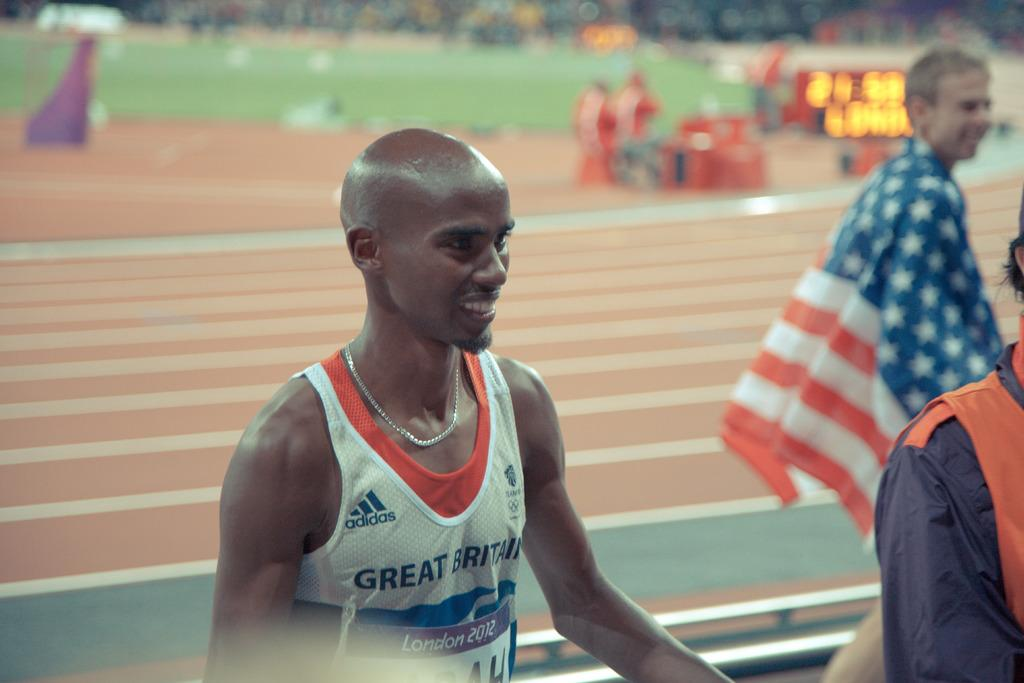<image>
Share a concise interpretation of the image provided. Runner wearing Great Britain shirt with a London 2012 race bib. 